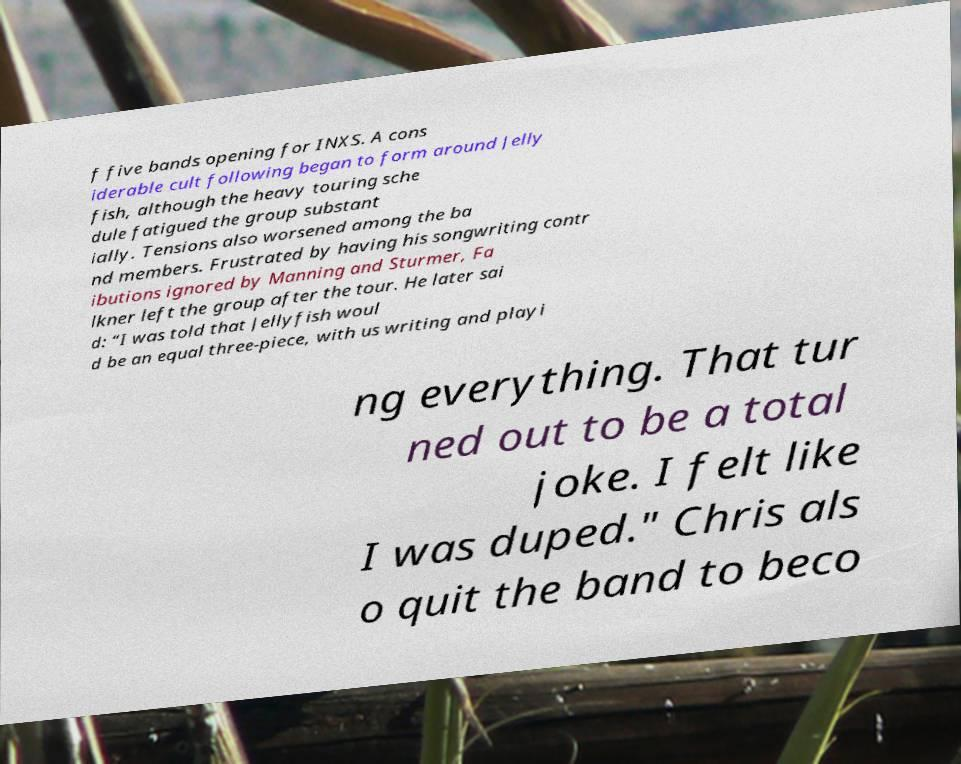Please read and relay the text visible in this image. What does it say? f five bands opening for INXS. A cons iderable cult following began to form around Jelly fish, although the heavy touring sche dule fatigued the group substant ially. Tensions also worsened among the ba nd members. Frustrated by having his songwriting contr ibutions ignored by Manning and Sturmer, Fa lkner left the group after the tour. He later sai d: “I was told that Jellyfish woul d be an equal three-piece, with us writing and playi ng everything. That tur ned out to be a total joke. I felt like I was duped." Chris als o quit the band to beco 